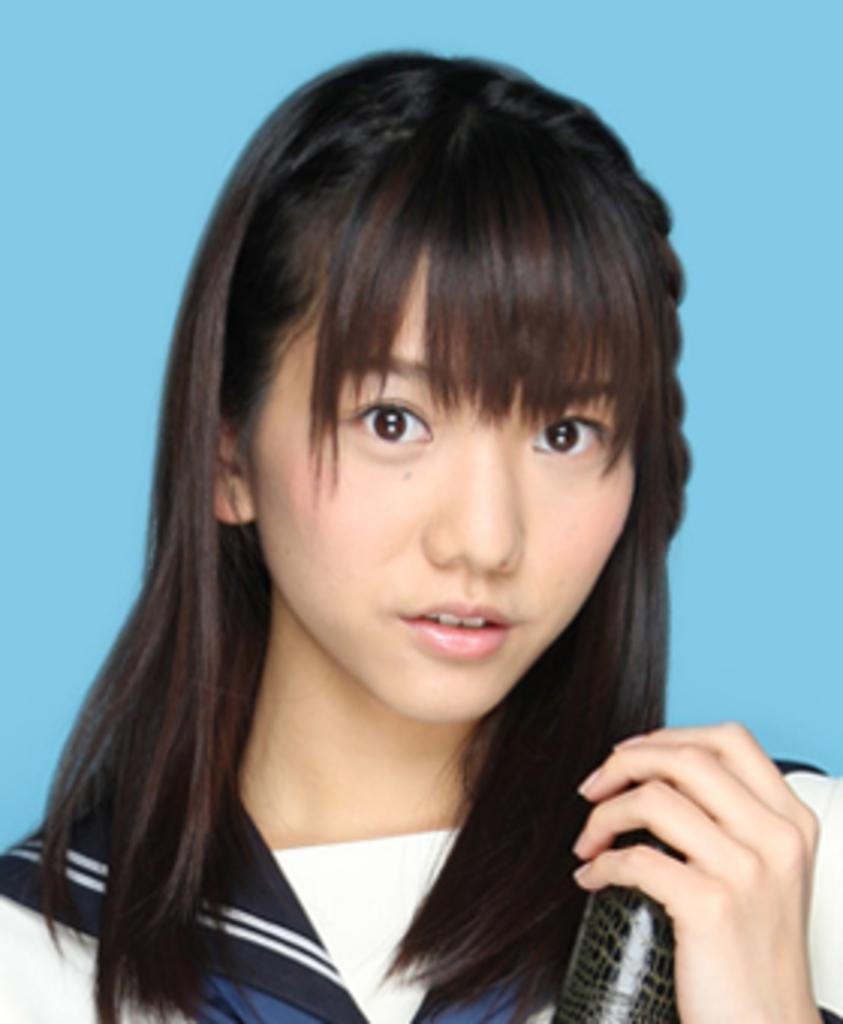Who is the main subject in the image? There is a girl in the image. What is the girl wearing? The girl is wearing a t-shirt. Can you describe what the girl is holding in her hand? The girl appears to be holding a black object in her hand. What day of the week is it in the image? The day of the week is not mentioned or visible in the image. Can you hear a bell ringing in the image? There is no auditory information provided in the image, so it is impossible to determine if a bell is ringing. 